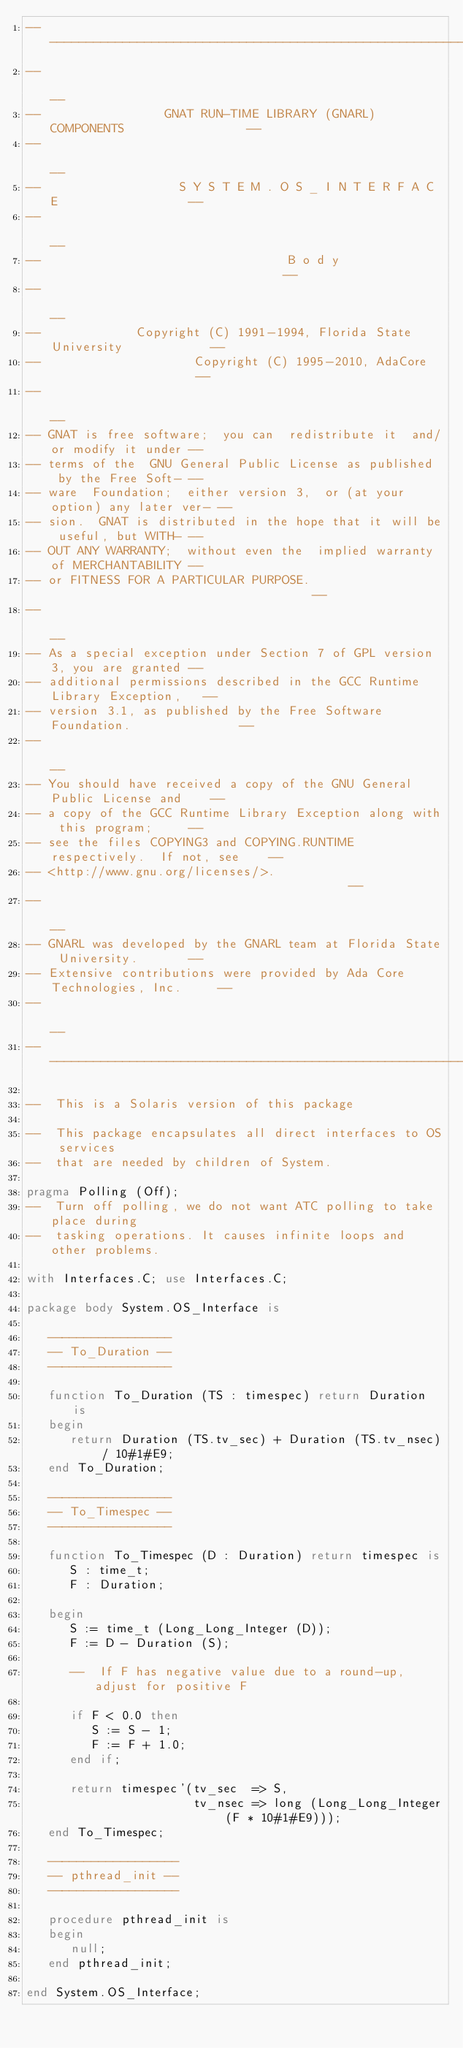Convert code to text. <code><loc_0><loc_0><loc_500><loc_500><_Ada_>------------------------------------------------------------------------------
--                                                                          --
--                 GNAT RUN-TIME LIBRARY (GNARL) COMPONENTS                 --
--                                                                          --
--                   S Y S T E M . O S _ I N T E R F A C E                  --
--                                                                          --
--                                  B o d y                                 --
--                                                                          --
--             Copyright (C) 1991-1994, Florida State University            --
--                     Copyright (C) 1995-2010, AdaCore                     --
--                                                                          --
-- GNAT is free software;  you can  redistribute it  and/or modify it under --
-- terms of the  GNU General Public License as published  by the Free Soft- --
-- ware  Foundation;  either version 3,  or (at your option) any later ver- --
-- sion.  GNAT is distributed in the hope that it will be useful, but WITH- --
-- OUT ANY WARRANTY;  without even the  implied warranty of MERCHANTABILITY --
-- or FITNESS FOR A PARTICULAR PURPOSE.                                     --
--                                                                          --
-- As a special exception under Section 7 of GPL version 3, you are granted --
-- additional permissions described in the GCC Runtime Library Exception,   --
-- version 3.1, as published by the Free Software Foundation.               --
--                                                                          --
-- You should have received a copy of the GNU General Public License and    --
-- a copy of the GCC Runtime Library Exception along with this program;     --
-- see the files COPYING3 and COPYING.RUNTIME respectively.  If not, see    --
-- <http://www.gnu.org/licenses/>.                                          --
--                                                                          --
-- GNARL was developed by the GNARL team at Florida State University.       --
-- Extensive contributions were provided by Ada Core Technologies, Inc.     --
--                                                                          --
------------------------------------------------------------------------------

--  This is a Solaris version of this package

--  This package encapsulates all direct interfaces to OS services
--  that are needed by children of System.

pragma Polling (Off);
--  Turn off polling, we do not want ATC polling to take place during
--  tasking operations. It causes infinite loops and other problems.

with Interfaces.C; use Interfaces.C;

package body System.OS_Interface is

   -----------------
   -- To_Duration --
   -----------------

   function To_Duration (TS : timespec) return Duration is
   begin
      return Duration (TS.tv_sec) + Duration (TS.tv_nsec) / 10#1#E9;
   end To_Duration;

   -----------------
   -- To_Timespec --
   -----------------

   function To_Timespec (D : Duration) return timespec is
      S : time_t;
      F : Duration;

   begin
      S := time_t (Long_Long_Integer (D));
      F := D - Duration (S);

      --  If F has negative value due to a round-up, adjust for positive F

      if F < 0.0 then
         S := S - 1;
         F := F + 1.0;
      end if;

      return timespec'(tv_sec  => S,
                       tv_nsec => long (Long_Long_Integer (F * 10#1#E9)));
   end To_Timespec;

   ------------------
   -- pthread_init --
   ------------------

   procedure pthread_init is
   begin
      null;
   end pthread_init;

end System.OS_Interface;
</code> 